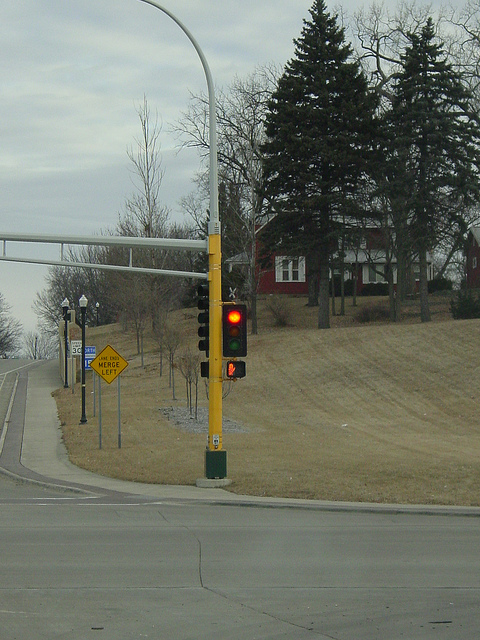Identify the text contained in this image. MEAGE LEFT 30 